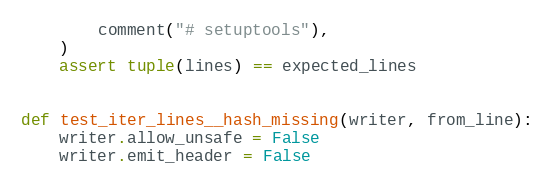Convert code to text. <code><loc_0><loc_0><loc_500><loc_500><_Python_>        comment("# setuptools"),
    )
    assert tuple(lines) == expected_lines


def test_iter_lines__hash_missing(writer, from_line):
    writer.allow_unsafe = False
    writer.emit_header = False</code> 